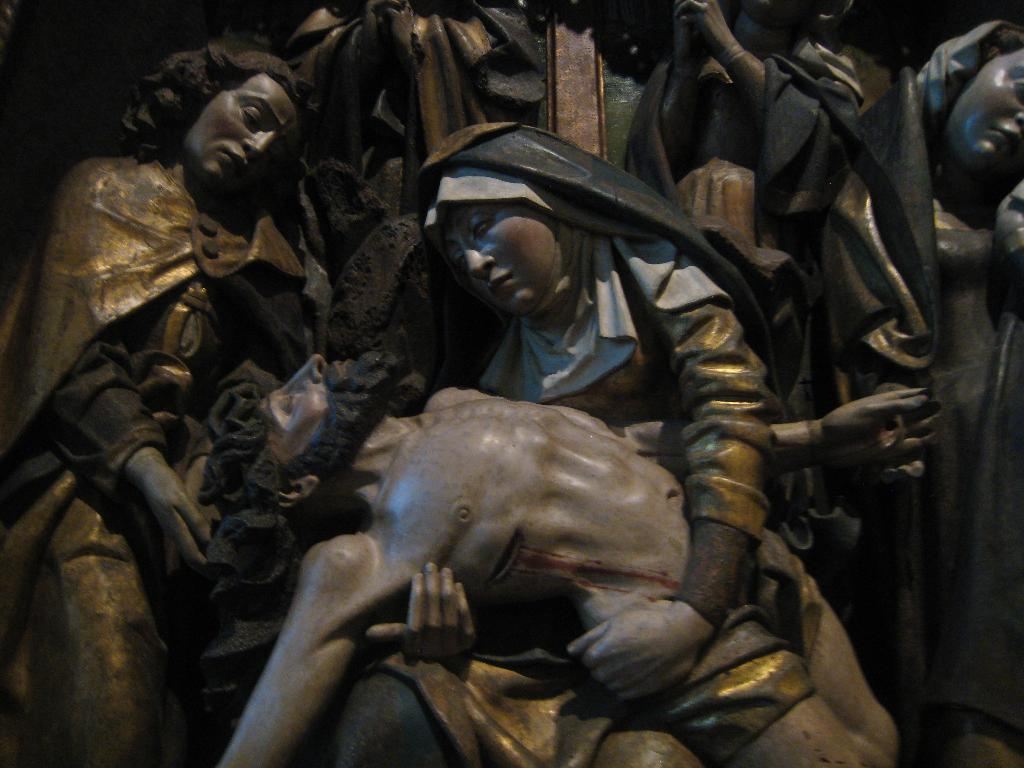What is the main subject of the image? The entire image is covered with sculptures. Can you describe the appearance of the sculptures? Unfortunately, the provided facts do not include any details about the appearance of the sculptures. Are there any other objects or subjects present in the image besides the sculptures? No, according to the facts, the entire image is covered with sculptures, so there are no other objects or subjects present. What statement does the laborer make about the sculptures in the image? There is no laborer present in the image, so it is not possible to answer this question. 